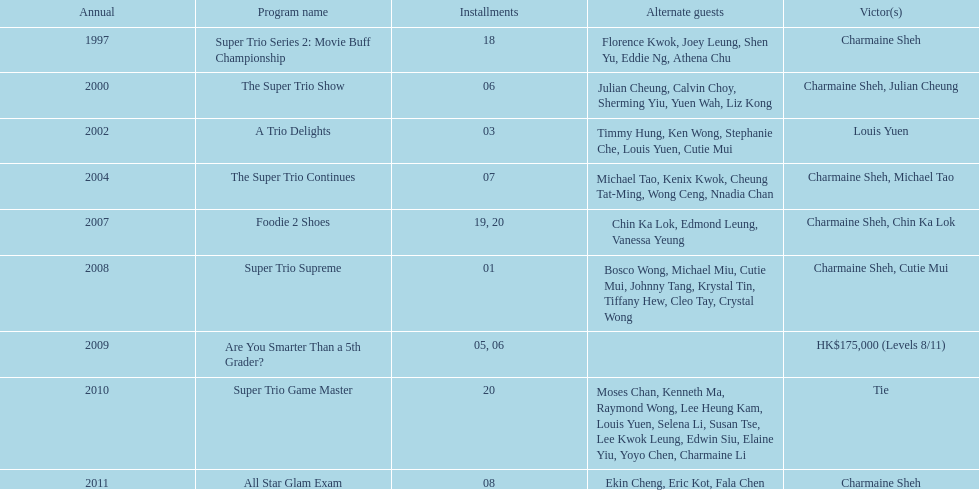What is the number of other guests in the 2002 show "a trio delights"? 5. 